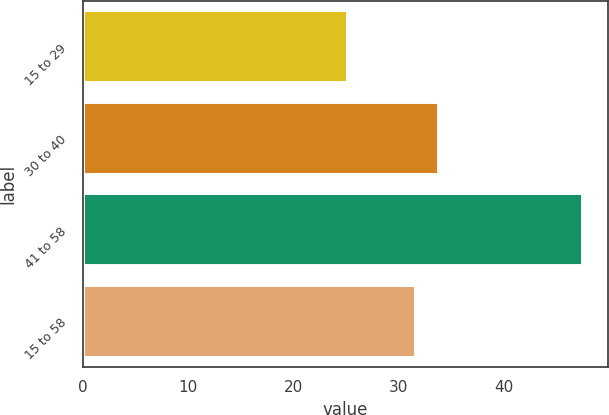Convert chart. <chart><loc_0><loc_0><loc_500><loc_500><bar_chart><fcel>15 to 29<fcel>30 to 40<fcel>41 to 58<fcel>15 to 58<nl><fcel>25.21<fcel>33.87<fcel>47.52<fcel>31.64<nl></chart> 